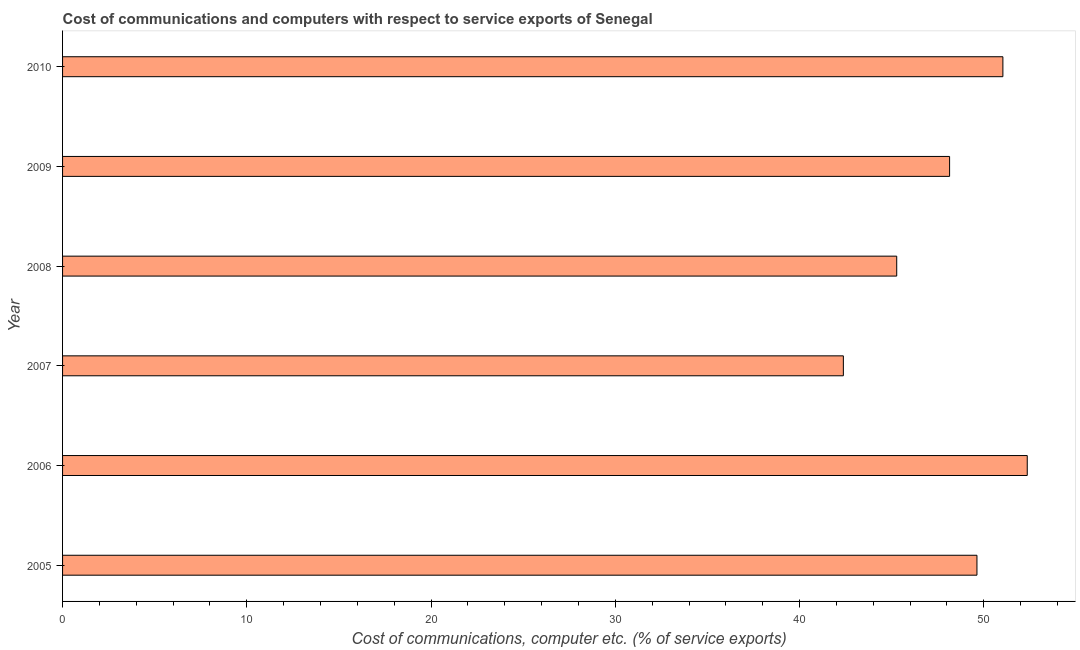Does the graph contain grids?
Keep it short and to the point. No. What is the title of the graph?
Provide a succinct answer. Cost of communications and computers with respect to service exports of Senegal. What is the label or title of the X-axis?
Give a very brief answer. Cost of communications, computer etc. (% of service exports). What is the cost of communications and computer in 2005?
Give a very brief answer. 49.63. Across all years, what is the maximum cost of communications and computer?
Your response must be concise. 52.36. Across all years, what is the minimum cost of communications and computer?
Provide a succinct answer. 42.38. In which year was the cost of communications and computer maximum?
Give a very brief answer. 2006. What is the sum of the cost of communications and computer?
Your response must be concise. 288.82. What is the difference between the cost of communications and computer in 2005 and 2010?
Offer a very short reply. -1.41. What is the average cost of communications and computer per year?
Provide a succinct answer. 48.14. What is the median cost of communications and computer?
Your answer should be compact. 48.89. What is the ratio of the cost of communications and computer in 2005 to that in 2008?
Provide a short and direct response. 1.1. Is the cost of communications and computer in 2005 less than that in 2009?
Your response must be concise. No. Is the difference between the cost of communications and computer in 2006 and 2008 greater than the difference between any two years?
Give a very brief answer. No. What is the difference between the highest and the second highest cost of communications and computer?
Offer a terse response. 1.32. What is the difference between the highest and the lowest cost of communications and computer?
Provide a succinct answer. 9.98. How many bars are there?
Offer a very short reply. 6. How many years are there in the graph?
Provide a succinct answer. 6. Are the values on the major ticks of X-axis written in scientific E-notation?
Provide a succinct answer. No. What is the Cost of communications, computer etc. (% of service exports) in 2005?
Your response must be concise. 49.63. What is the Cost of communications, computer etc. (% of service exports) of 2006?
Offer a very short reply. 52.36. What is the Cost of communications, computer etc. (% of service exports) of 2007?
Give a very brief answer. 42.38. What is the Cost of communications, computer etc. (% of service exports) of 2008?
Your answer should be very brief. 45.27. What is the Cost of communications, computer etc. (% of service exports) in 2009?
Your answer should be compact. 48.14. What is the Cost of communications, computer etc. (% of service exports) in 2010?
Provide a short and direct response. 51.04. What is the difference between the Cost of communications, computer etc. (% of service exports) in 2005 and 2006?
Provide a succinct answer. -2.73. What is the difference between the Cost of communications, computer etc. (% of service exports) in 2005 and 2007?
Make the answer very short. 7.25. What is the difference between the Cost of communications, computer etc. (% of service exports) in 2005 and 2008?
Your answer should be very brief. 4.36. What is the difference between the Cost of communications, computer etc. (% of service exports) in 2005 and 2009?
Ensure brevity in your answer.  1.48. What is the difference between the Cost of communications, computer etc. (% of service exports) in 2005 and 2010?
Your answer should be very brief. -1.41. What is the difference between the Cost of communications, computer etc. (% of service exports) in 2006 and 2007?
Offer a terse response. 9.98. What is the difference between the Cost of communications, computer etc. (% of service exports) in 2006 and 2008?
Provide a succinct answer. 7.09. What is the difference between the Cost of communications, computer etc. (% of service exports) in 2006 and 2009?
Provide a short and direct response. 4.21. What is the difference between the Cost of communications, computer etc. (% of service exports) in 2006 and 2010?
Offer a very short reply. 1.32. What is the difference between the Cost of communications, computer etc. (% of service exports) in 2007 and 2008?
Give a very brief answer. -2.9. What is the difference between the Cost of communications, computer etc. (% of service exports) in 2007 and 2009?
Your response must be concise. -5.77. What is the difference between the Cost of communications, computer etc. (% of service exports) in 2007 and 2010?
Keep it short and to the point. -8.66. What is the difference between the Cost of communications, computer etc. (% of service exports) in 2008 and 2009?
Give a very brief answer. -2.87. What is the difference between the Cost of communications, computer etc. (% of service exports) in 2008 and 2010?
Give a very brief answer. -5.76. What is the difference between the Cost of communications, computer etc. (% of service exports) in 2009 and 2010?
Your answer should be very brief. -2.89. What is the ratio of the Cost of communications, computer etc. (% of service exports) in 2005 to that in 2006?
Keep it short and to the point. 0.95. What is the ratio of the Cost of communications, computer etc. (% of service exports) in 2005 to that in 2007?
Keep it short and to the point. 1.17. What is the ratio of the Cost of communications, computer etc. (% of service exports) in 2005 to that in 2008?
Your response must be concise. 1.1. What is the ratio of the Cost of communications, computer etc. (% of service exports) in 2005 to that in 2009?
Offer a terse response. 1.03. What is the ratio of the Cost of communications, computer etc. (% of service exports) in 2005 to that in 2010?
Make the answer very short. 0.97. What is the ratio of the Cost of communications, computer etc. (% of service exports) in 2006 to that in 2007?
Provide a succinct answer. 1.24. What is the ratio of the Cost of communications, computer etc. (% of service exports) in 2006 to that in 2008?
Give a very brief answer. 1.16. What is the ratio of the Cost of communications, computer etc. (% of service exports) in 2006 to that in 2009?
Ensure brevity in your answer.  1.09. What is the ratio of the Cost of communications, computer etc. (% of service exports) in 2006 to that in 2010?
Ensure brevity in your answer.  1.03. What is the ratio of the Cost of communications, computer etc. (% of service exports) in 2007 to that in 2008?
Your response must be concise. 0.94. What is the ratio of the Cost of communications, computer etc. (% of service exports) in 2007 to that in 2010?
Your answer should be compact. 0.83. What is the ratio of the Cost of communications, computer etc. (% of service exports) in 2008 to that in 2009?
Offer a terse response. 0.94. What is the ratio of the Cost of communications, computer etc. (% of service exports) in 2008 to that in 2010?
Ensure brevity in your answer.  0.89. What is the ratio of the Cost of communications, computer etc. (% of service exports) in 2009 to that in 2010?
Your answer should be very brief. 0.94. 